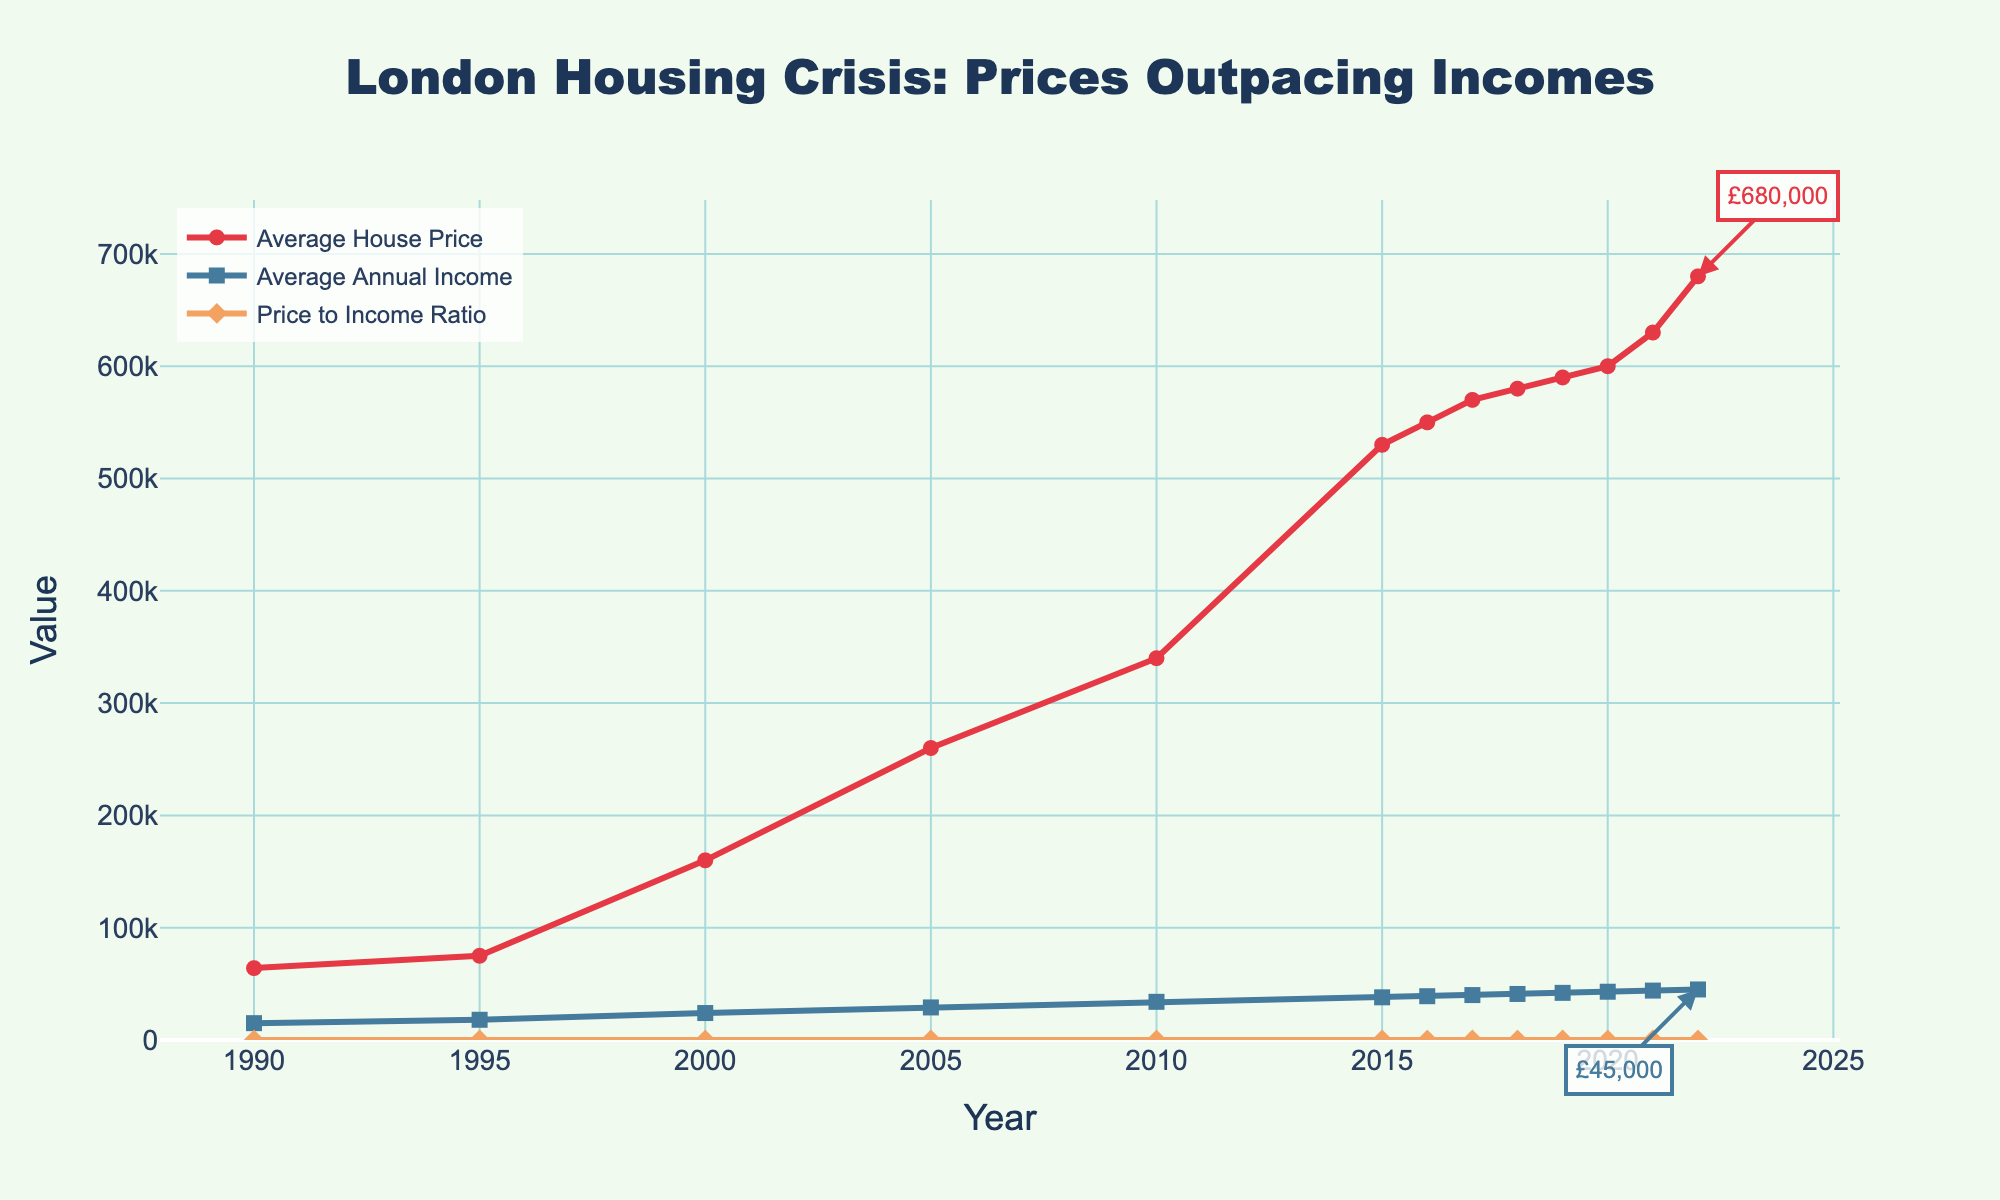what's the difference between the average house price and average annual income in 2022? Look at the data points for 2022. The average house price is £680,000, and the average annual income is £45,000. Subtract the income from the house price: £680,000 - £45,000 = £635,000
Answer: £635,000 has the average house price increased or decreased from 2000 to 2022? Find the data points for 2000 and 2022. In 2000, the average house price is £160,000, and in 2022 it is £680,000. Since £680,000 is greater than £160,000, the price has increased
Answer: increased what was the price to income ratio in 2015? To find the price to income ratio for a year, divide the average house price by the average annual income for that year. In 2015, the average house price was £530,000, and the average annual income was £38,000, so the ratio is £530,000 / £38,000 ≈ 13.95
Answer: 13.95 which year experienced the highest average house price? Inspect the values for average house prices across all years. The highest value is in 2022, with £680,000
Answer: 2022 how much did the average annual income increase from 1990 to 2022? Compare the average annual incomes in 1990 and 2022. In 1990, the income was £15,000, and in 2022, it was £45,000. The increase is £45,000 - £15,000 = £30,000
Answer: £30,000 which has grown faster, average house prices or average annual incomes from 1990 to 2022? Compare the growth of both metrics over the given years. Average house prices have grown from £64,000 to £680,000, a growth of £680,000 - £64,000 = £616,000. Average annual incomes grew from £15,000 to £45,000, a growth of £45,000 - £15,000 = £30,000. House prices have grown faster.
Answer: average house prices in which year did the price to income ratio first exceed 10? Calculate the price to income ratio for each year from the data. In 2005, the ratio is £260,000 / £29,000 ≈ 8.97 and in 2010, it's £340,000 / £34,000 = 10.00, so the year is 2010.
Answer: 2010 how did the average house price change from 2015 to 2016? Check the average house price in 2015 (£530,000) and in 2016 (£550,000). The difference is £550,000 - £530,000 = £20,000, so it increased by £20,000
Answer: increased by £20,000 